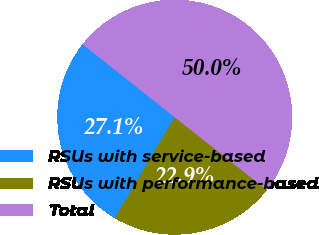Convert chart to OTSL. <chart><loc_0><loc_0><loc_500><loc_500><pie_chart><fcel>RSUs with service-based<fcel>RSUs with performance-based<fcel>Total<nl><fcel>27.13%<fcel>22.87%<fcel>50.0%<nl></chart> 